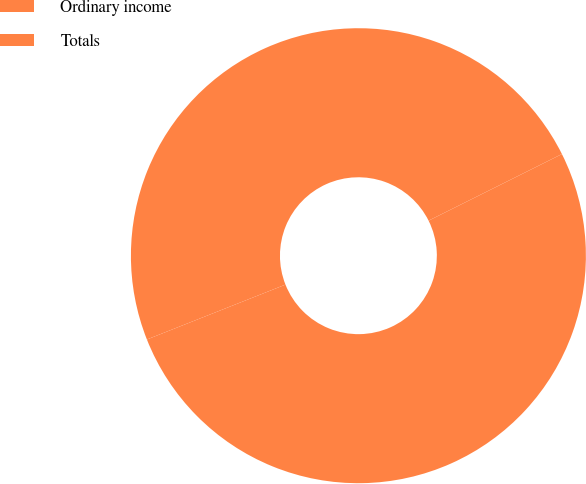Convert chart to OTSL. <chart><loc_0><loc_0><loc_500><loc_500><pie_chart><fcel>Ordinary income<fcel>Totals<nl><fcel>48.63%<fcel>51.37%<nl></chart> 